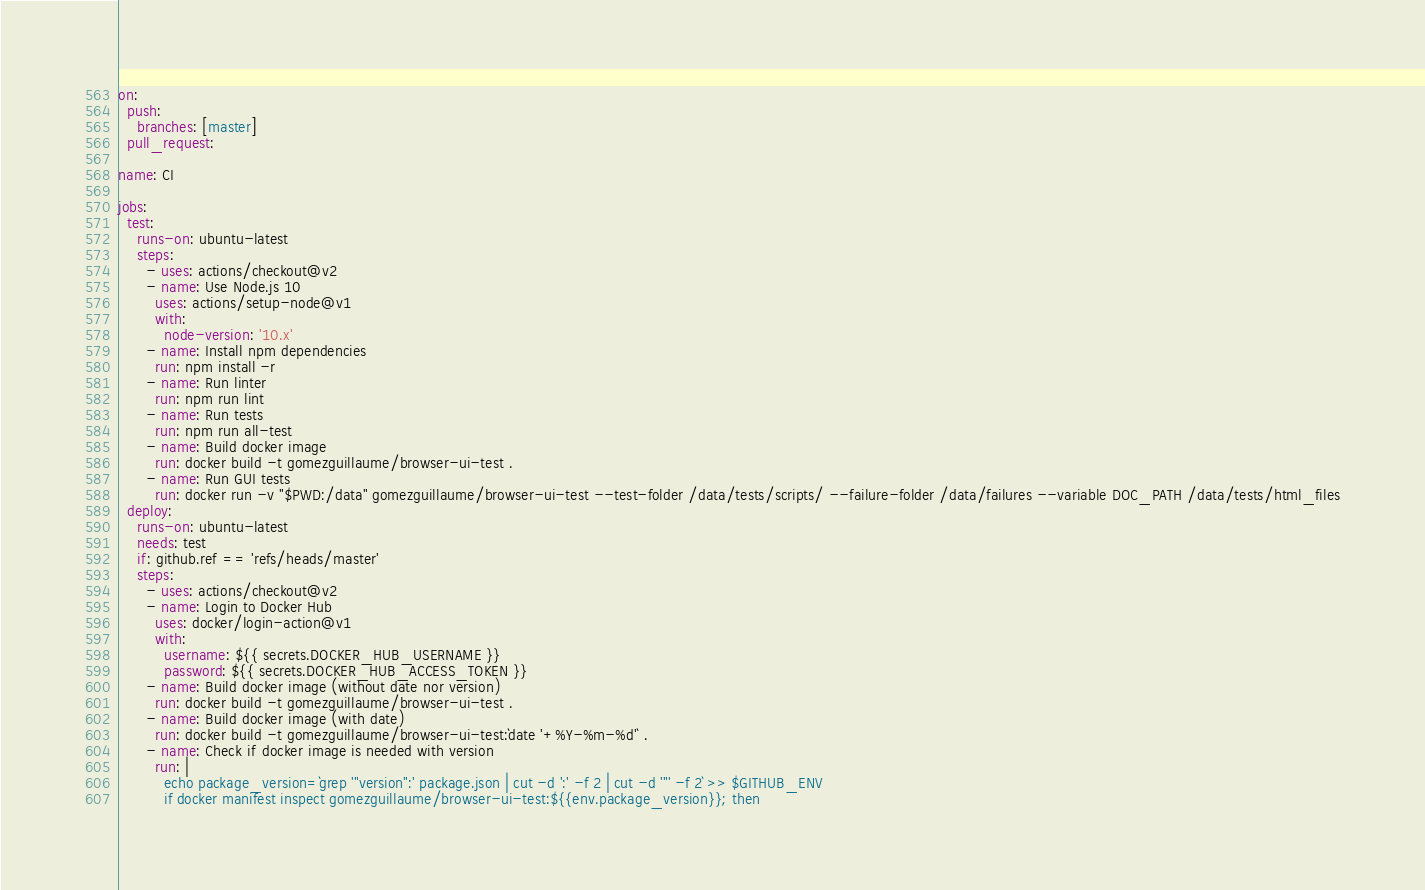Convert code to text. <code><loc_0><loc_0><loc_500><loc_500><_YAML_>on:
  push:
    branches: [master]
  pull_request:

name: CI

jobs:
  test:
    runs-on: ubuntu-latest
    steps:
      - uses: actions/checkout@v2
      - name: Use Node.js 10
        uses: actions/setup-node@v1
        with:
          node-version: '10.x'
      - name: Install npm dependencies
        run: npm install -r
      - name: Run linter
        run: npm run lint
      - name: Run tests
        run: npm run all-test
      - name: Build docker image
        run: docker build -t gomezguillaume/browser-ui-test .
      - name: Run GUI tests
        run: docker run -v "$PWD:/data" gomezguillaume/browser-ui-test --test-folder /data/tests/scripts/ --failure-folder /data/failures --variable DOC_PATH /data/tests/html_files
  deploy:
    runs-on: ubuntu-latest
    needs: test
    if: github.ref == 'refs/heads/master'
    steps:
      - uses: actions/checkout@v2
      - name: Login to Docker Hub
        uses: docker/login-action@v1
        with:
          username: ${{ secrets.DOCKER_HUB_USERNAME }}
          password: ${{ secrets.DOCKER_HUB_ACCESS_TOKEN }}
      - name: Build docker image (without date nor version)
        run: docker build -t gomezguillaume/browser-ui-test .
      - name: Build docker image (with date)
        run: docker build -t gomezguillaume/browser-ui-test:`date '+%Y-%m-%d'` .
      - name: Check if docker image is needed with version
        run: |
          echo package_version=`grep '"version":' package.json | cut -d ':' -f 2 | cut -d '"' -f 2` >> $GITHUB_ENV
          if docker manifest inspect gomezguillaume/browser-ui-test:${{env.package_version}}; then</code> 